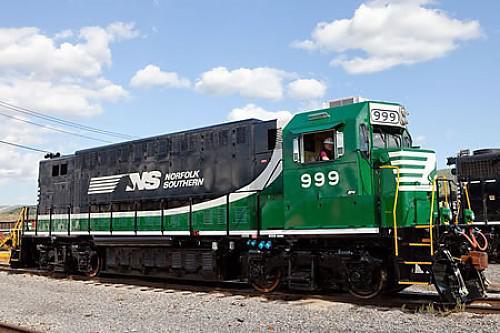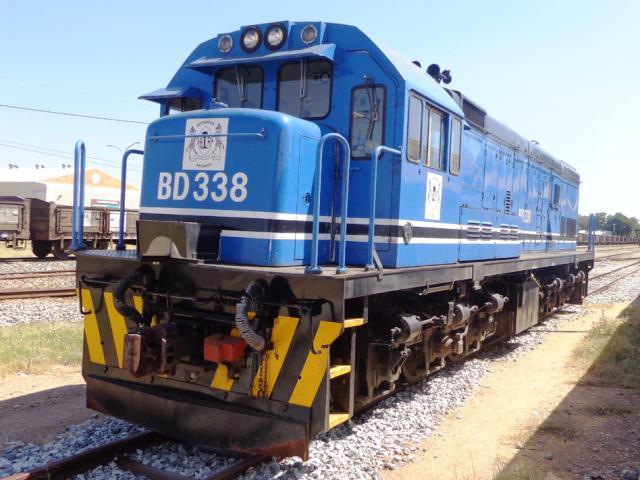The first image is the image on the left, the second image is the image on the right. Considering the images on both sides, is "1 locomotive has CSX painted on the side." valid? Answer yes or no. No. 